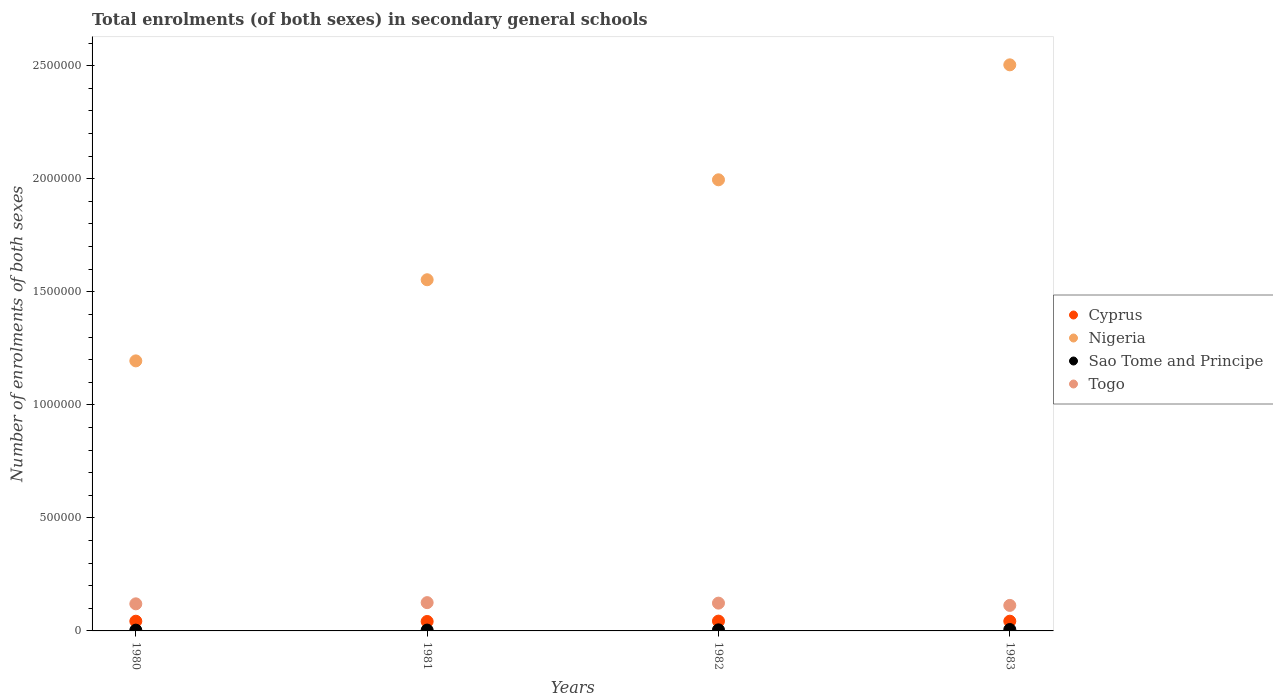How many different coloured dotlines are there?
Your answer should be very brief. 4. Is the number of dotlines equal to the number of legend labels?
Provide a short and direct response. Yes. What is the number of enrolments in secondary schools in Nigeria in 1980?
Keep it short and to the point. 1.19e+06. Across all years, what is the maximum number of enrolments in secondary schools in Nigeria?
Keep it short and to the point. 2.50e+06. Across all years, what is the minimum number of enrolments in secondary schools in Nigeria?
Your answer should be compact. 1.19e+06. In which year was the number of enrolments in secondary schools in Cyprus maximum?
Keep it short and to the point. 1982. In which year was the number of enrolments in secondary schools in Sao Tome and Principe minimum?
Give a very brief answer. 1980. What is the total number of enrolments in secondary schools in Sao Tome and Principe in the graph?
Ensure brevity in your answer.  1.80e+04. What is the difference between the number of enrolments in secondary schools in Sao Tome and Principe in 1981 and that in 1983?
Your response must be concise. -2475. What is the difference between the number of enrolments in secondary schools in Nigeria in 1983 and the number of enrolments in secondary schools in Cyprus in 1980?
Give a very brief answer. 2.46e+06. What is the average number of enrolments in secondary schools in Togo per year?
Make the answer very short. 1.20e+05. In the year 1983, what is the difference between the number of enrolments in secondary schools in Togo and number of enrolments in secondary schools in Nigeria?
Your answer should be very brief. -2.39e+06. What is the ratio of the number of enrolments in secondary schools in Cyprus in 1981 to that in 1983?
Provide a short and direct response. 0.97. Is the difference between the number of enrolments in secondary schools in Togo in 1980 and 1982 greater than the difference between the number of enrolments in secondary schools in Nigeria in 1980 and 1982?
Your response must be concise. Yes. What is the difference between the highest and the second highest number of enrolments in secondary schools in Sao Tome and Principe?
Ensure brevity in your answer.  1462. What is the difference between the highest and the lowest number of enrolments in secondary schools in Cyprus?
Your answer should be compact. 1544. Is the sum of the number of enrolments in secondary schools in Togo in 1982 and 1983 greater than the maximum number of enrolments in secondary schools in Cyprus across all years?
Give a very brief answer. Yes. Is it the case that in every year, the sum of the number of enrolments in secondary schools in Nigeria and number of enrolments in secondary schools in Togo  is greater than the number of enrolments in secondary schools in Cyprus?
Offer a terse response. Yes. Does the number of enrolments in secondary schools in Cyprus monotonically increase over the years?
Offer a very short reply. No. Is the number of enrolments in secondary schools in Cyprus strictly greater than the number of enrolments in secondary schools in Nigeria over the years?
Your answer should be very brief. No. How many dotlines are there?
Give a very brief answer. 4. How many years are there in the graph?
Provide a short and direct response. 4. Are the values on the major ticks of Y-axis written in scientific E-notation?
Offer a very short reply. No. Does the graph contain any zero values?
Your response must be concise. No. Where does the legend appear in the graph?
Make the answer very short. Center right. How many legend labels are there?
Make the answer very short. 4. What is the title of the graph?
Your answer should be very brief. Total enrolments (of both sexes) in secondary general schools. What is the label or title of the Y-axis?
Keep it short and to the point. Number of enrolments of both sexes. What is the Number of enrolments of both sexes of Cyprus in 1980?
Provide a short and direct response. 4.30e+04. What is the Number of enrolments of both sexes of Nigeria in 1980?
Make the answer very short. 1.19e+06. What is the Number of enrolments of both sexes in Sao Tome and Principe in 1980?
Offer a terse response. 3415. What is the Number of enrolments of both sexes of Togo in 1980?
Your response must be concise. 1.20e+05. What is the Number of enrolments of both sexes of Cyprus in 1981?
Your answer should be very brief. 4.18e+04. What is the Number of enrolments of both sexes in Nigeria in 1981?
Your answer should be very brief. 1.55e+06. What is the Number of enrolments of both sexes of Sao Tome and Principe in 1981?
Keep it short and to the point. 3685. What is the Number of enrolments of both sexes in Togo in 1981?
Offer a terse response. 1.25e+05. What is the Number of enrolments of both sexes of Cyprus in 1982?
Provide a succinct answer. 4.33e+04. What is the Number of enrolments of both sexes of Nigeria in 1982?
Ensure brevity in your answer.  2.00e+06. What is the Number of enrolments of both sexes of Sao Tome and Principe in 1982?
Your answer should be compact. 4698. What is the Number of enrolments of both sexes of Togo in 1982?
Your response must be concise. 1.23e+05. What is the Number of enrolments of both sexes of Cyprus in 1983?
Keep it short and to the point. 4.30e+04. What is the Number of enrolments of both sexes in Nigeria in 1983?
Your answer should be very brief. 2.50e+06. What is the Number of enrolments of both sexes of Sao Tome and Principe in 1983?
Offer a terse response. 6160. What is the Number of enrolments of both sexes in Togo in 1983?
Give a very brief answer. 1.13e+05. Across all years, what is the maximum Number of enrolments of both sexes of Cyprus?
Offer a terse response. 4.33e+04. Across all years, what is the maximum Number of enrolments of both sexes of Nigeria?
Provide a succinct answer. 2.50e+06. Across all years, what is the maximum Number of enrolments of both sexes of Sao Tome and Principe?
Offer a terse response. 6160. Across all years, what is the maximum Number of enrolments of both sexes in Togo?
Your response must be concise. 1.25e+05. Across all years, what is the minimum Number of enrolments of both sexes in Cyprus?
Your answer should be compact. 4.18e+04. Across all years, what is the minimum Number of enrolments of both sexes of Nigeria?
Your answer should be compact. 1.19e+06. Across all years, what is the minimum Number of enrolments of both sexes in Sao Tome and Principe?
Your answer should be very brief. 3415. Across all years, what is the minimum Number of enrolments of both sexes in Togo?
Your answer should be compact. 1.13e+05. What is the total Number of enrolments of both sexes of Cyprus in the graph?
Provide a short and direct response. 1.71e+05. What is the total Number of enrolments of both sexes of Nigeria in the graph?
Your answer should be very brief. 7.25e+06. What is the total Number of enrolments of both sexes of Sao Tome and Principe in the graph?
Your answer should be compact. 1.80e+04. What is the total Number of enrolments of both sexes of Togo in the graph?
Keep it short and to the point. 4.81e+05. What is the difference between the Number of enrolments of both sexes of Cyprus in 1980 and that in 1981?
Your answer should be very brief. 1163. What is the difference between the Number of enrolments of both sexes in Nigeria in 1980 and that in 1981?
Your answer should be compact. -3.59e+05. What is the difference between the Number of enrolments of both sexes in Sao Tome and Principe in 1980 and that in 1981?
Your answer should be very brief. -270. What is the difference between the Number of enrolments of both sexes of Togo in 1980 and that in 1981?
Your answer should be very brief. -5321. What is the difference between the Number of enrolments of both sexes in Cyprus in 1980 and that in 1982?
Your response must be concise. -381. What is the difference between the Number of enrolments of both sexes of Nigeria in 1980 and that in 1982?
Keep it short and to the point. -8.01e+05. What is the difference between the Number of enrolments of both sexes of Sao Tome and Principe in 1980 and that in 1982?
Provide a short and direct response. -1283. What is the difference between the Number of enrolments of both sexes of Togo in 1980 and that in 1982?
Provide a succinct answer. -3124. What is the difference between the Number of enrolments of both sexes in Cyprus in 1980 and that in 1983?
Ensure brevity in your answer.  -43. What is the difference between the Number of enrolments of both sexes of Nigeria in 1980 and that in 1983?
Provide a succinct answer. -1.31e+06. What is the difference between the Number of enrolments of both sexes in Sao Tome and Principe in 1980 and that in 1983?
Offer a terse response. -2745. What is the difference between the Number of enrolments of both sexes in Togo in 1980 and that in 1983?
Offer a very short reply. 6940. What is the difference between the Number of enrolments of both sexes in Cyprus in 1981 and that in 1982?
Your answer should be very brief. -1544. What is the difference between the Number of enrolments of both sexes in Nigeria in 1981 and that in 1982?
Keep it short and to the point. -4.42e+05. What is the difference between the Number of enrolments of both sexes of Sao Tome and Principe in 1981 and that in 1982?
Your response must be concise. -1013. What is the difference between the Number of enrolments of both sexes of Togo in 1981 and that in 1982?
Ensure brevity in your answer.  2197. What is the difference between the Number of enrolments of both sexes of Cyprus in 1981 and that in 1983?
Keep it short and to the point. -1206. What is the difference between the Number of enrolments of both sexes of Nigeria in 1981 and that in 1983?
Keep it short and to the point. -9.51e+05. What is the difference between the Number of enrolments of both sexes in Sao Tome and Principe in 1981 and that in 1983?
Your answer should be compact. -2475. What is the difference between the Number of enrolments of both sexes of Togo in 1981 and that in 1983?
Your response must be concise. 1.23e+04. What is the difference between the Number of enrolments of both sexes in Cyprus in 1982 and that in 1983?
Make the answer very short. 338. What is the difference between the Number of enrolments of both sexes of Nigeria in 1982 and that in 1983?
Ensure brevity in your answer.  -5.09e+05. What is the difference between the Number of enrolments of both sexes of Sao Tome and Principe in 1982 and that in 1983?
Keep it short and to the point. -1462. What is the difference between the Number of enrolments of both sexes of Togo in 1982 and that in 1983?
Give a very brief answer. 1.01e+04. What is the difference between the Number of enrolments of both sexes in Cyprus in 1980 and the Number of enrolments of both sexes in Nigeria in 1981?
Your response must be concise. -1.51e+06. What is the difference between the Number of enrolments of both sexes in Cyprus in 1980 and the Number of enrolments of both sexes in Sao Tome and Principe in 1981?
Your answer should be compact. 3.93e+04. What is the difference between the Number of enrolments of both sexes of Cyprus in 1980 and the Number of enrolments of both sexes of Togo in 1981?
Ensure brevity in your answer.  -8.22e+04. What is the difference between the Number of enrolments of both sexes in Nigeria in 1980 and the Number of enrolments of both sexes in Sao Tome and Principe in 1981?
Ensure brevity in your answer.  1.19e+06. What is the difference between the Number of enrolments of both sexes in Nigeria in 1980 and the Number of enrolments of both sexes in Togo in 1981?
Give a very brief answer. 1.07e+06. What is the difference between the Number of enrolments of both sexes in Sao Tome and Principe in 1980 and the Number of enrolments of both sexes in Togo in 1981?
Ensure brevity in your answer.  -1.22e+05. What is the difference between the Number of enrolments of both sexes in Cyprus in 1980 and the Number of enrolments of both sexes in Nigeria in 1982?
Offer a terse response. -1.95e+06. What is the difference between the Number of enrolments of both sexes in Cyprus in 1980 and the Number of enrolments of both sexes in Sao Tome and Principe in 1982?
Provide a short and direct response. 3.83e+04. What is the difference between the Number of enrolments of both sexes of Cyprus in 1980 and the Number of enrolments of both sexes of Togo in 1982?
Your answer should be very brief. -8.00e+04. What is the difference between the Number of enrolments of both sexes in Nigeria in 1980 and the Number of enrolments of both sexes in Sao Tome and Principe in 1982?
Give a very brief answer. 1.19e+06. What is the difference between the Number of enrolments of both sexes in Nigeria in 1980 and the Number of enrolments of both sexes in Togo in 1982?
Give a very brief answer. 1.07e+06. What is the difference between the Number of enrolments of both sexes in Sao Tome and Principe in 1980 and the Number of enrolments of both sexes in Togo in 1982?
Provide a succinct answer. -1.20e+05. What is the difference between the Number of enrolments of both sexes in Cyprus in 1980 and the Number of enrolments of both sexes in Nigeria in 1983?
Offer a very short reply. -2.46e+06. What is the difference between the Number of enrolments of both sexes in Cyprus in 1980 and the Number of enrolments of both sexes in Sao Tome and Principe in 1983?
Offer a very short reply. 3.68e+04. What is the difference between the Number of enrolments of both sexes of Cyprus in 1980 and the Number of enrolments of both sexes of Togo in 1983?
Offer a terse response. -6.99e+04. What is the difference between the Number of enrolments of both sexes in Nigeria in 1980 and the Number of enrolments of both sexes in Sao Tome and Principe in 1983?
Ensure brevity in your answer.  1.19e+06. What is the difference between the Number of enrolments of both sexes in Nigeria in 1980 and the Number of enrolments of both sexes in Togo in 1983?
Provide a succinct answer. 1.08e+06. What is the difference between the Number of enrolments of both sexes of Sao Tome and Principe in 1980 and the Number of enrolments of both sexes of Togo in 1983?
Provide a succinct answer. -1.09e+05. What is the difference between the Number of enrolments of both sexes of Cyprus in 1981 and the Number of enrolments of both sexes of Nigeria in 1982?
Your response must be concise. -1.95e+06. What is the difference between the Number of enrolments of both sexes in Cyprus in 1981 and the Number of enrolments of both sexes in Sao Tome and Principe in 1982?
Keep it short and to the point. 3.71e+04. What is the difference between the Number of enrolments of both sexes of Cyprus in 1981 and the Number of enrolments of both sexes of Togo in 1982?
Provide a succinct answer. -8.11e+04. What is the difference between the Number of enrolments of both sexes of Nigeria in 1981 and the Number of enrolments of both sexes of Sao Tome and Principe in 1982?
Your answer should be compact. 1.55e+06. What is the difference between the Number of enrolments of both sexes in Nigeria in 1981 and the Number of enrolments of both sexes in Togo in 1982?
Your answer should be very brief. 1.43e+06. What is the difference between the Number of enrolments of both sexes of Sao Tome and Principe in 1981 and the Number of enrolments of both sexes of Togo in 1982?
Give a very brief answer. -1.19e+05. What is the difference between the Number of enrolments of both sexes of Cyprus in 1981 and the Number of enrolments of both sexes of Nigeria in 1983?
Your response must be concise. -2.46e+06. What is the difference between the Number of enrolments of both sexes in Cyprus in 1981 and the Number of enrolments of both sexes in Sao Tome and Principe in 1983?
Your answer should be compact. 3.56e+04. What is the difference between the Number of enrolments of both sexes in Cyprus in 1981 and the Number of enrolments of both sexes in Togo in 1983?
Offer a very short reply. -7.11e+04. What is the difference between the Number of enrolments of both sexes of Nigeria in 1981 and the Number of enrolments of both sexes of Sao Tome and Principe in 1983?
Make the answer very short. 1.55e+06. What is the difference between the Number of enrolments of both sexes of Nigeria in 1981 and the Number of enrolments of both sexes of Togo in 1983?
Offer a very short reply. 1.44e+06. What is the difference between the Number of enrolments of both sexes in Sao Tome and Principe in 1981 and the Number of enrolments of both sexes in Togo in 1983?
Make the answer very short. -1.09e+05. What is the difference between the Number of enrolments of both sexes in Cyprus in 1982 and the Number of enrolments of both sexes in Nigeria in 1983?
Provide a succinct answer. -2.46e+06. What is the difference between the Number of enrolments of both sexes in Cyprus in 1982 and the Number of enrolments of both sexes in Sao Tome and Principe in 1983?
Offer a very short reply. 3.72e+04. What is the difference between the Number of enrolments of both sexes in Cyprus in 1982 and the Number of enrolments of both sexes in Togo in 1983?
Your response must be concise. -6.95e+04. What is the difference between the Number of enrolments of both sexes in Nigeria in 1982 and the Number of enrolments of both sexes in Sao Tome and Principe in 1983?
Give a very brief answer. 1.99e+06. What is the difference between the Number of enrolments of both sexes of Nigeria in 1982 and the Number of enrolments of both sexes of Togo in 1983?
Your answer should be compact. 1.88e+06. What is the difference between the Number of enrolments of both sexes of Sao Tome and Principe in 1982 and the Number of enrolments of both sexes of Togo in 1983?
Offer a terse response. -1.08e+05. What is the average Number of enrolments of both sexes in Cyprus per year?
Your response must be concise. 4.28e+04. What is the average Number of enrolments of both sexes of Nigeria per year?
Your answer should be compact. 1.81e+06. What is the average Number of enrolments of both sexes of Sao Tome and Principe per year?
Ensure brevity in your answer.  4489.5. What is the average Number of enrolments of both sexes in Togo per year?
Provide a short and direct response. 1.20e+05. In the year 1980, what is the difference between the Number of enrolments of both sexes of Cyprus and Number of enrolments of both sexes of Nigeria?
Provide a short and direct response. -1.15e+06. In the year 1980, what is the difference between the Number of enrolments of both sexes of Cyprus and Number of enrolments of both sexes of Sao Tome and Principe?
Give a very brief answer. 3.95e+04. In the year 1980, what is the difference between the Number of enrolments of both sexes in Cyprus and Number of enrolments of both sexes in Togo?
Provide a short and direct response. -7.68e+04. In the year 1980, what is the difference between the Number of enrolments of both sexes in Nigeria and Number of enrolments of both sexes in Sao Tome and Principe?
Give a very brief answer. 1.19e+06. In the year 1980, what is the difference between the Number of enrolments of both sexes of Nigeria and Number of enrolments of both sexes of Togo?
Ensure brevity in your answer.  1.07e+06. In the year 1980, what is the difference between the Number of enrolments of both sexes in Sao Tome and Principe and Number of enrolments of both sexes in Togo?
Make the answer very short. -1.16e+05. In the year 1981, what is the difference between the Number of enrolments of both sexes of Cyprus and Number of enrolments of both sexes of Nigeria?
Your answer should be compact. -1.51e+06. In the year 1981, what is the difference between the Number of enrolments of both sexes of Cyprus and Number of enrolments of both sexes of Sao Tome and Principe?
Give a very brief answer. 3.81e+04. In the year 1981, what is the difference between the Number of enrolments of both sexes of Cyprus and Number of enrolments of both sexes of Togo?
Ensure brevity in your answer.  -8.33e+04. In the year 1981, what is the difference between the Number of enrolments of both sexes of Nigeria and Number of enrolments of both sexes of Sao Tome and Principe?
Offer a terse response. 1.55e+06. In the year 1981, what is the difference between the Number of enrolments of both sexes in Nigeria and Number of enrolments of both sexes in Togo?
Your answer should be compact. 1.43e+06. In the year 1981, what is the difference between the Number of enrolments of both sexes of Sao Tome and Principe and Number of enrolments of both sexes of Togo?
Provide a short and direct response. -1.21e+05. In the year 1982, what is the difference between the Number of enrolments of both sexes of Cyprus and Number of enrolments of both sexes of Nigeria?
Your answer should be compact. -1.95e+06. In the year 1982, what is the difference between the Number of enrolments of both sexes in Cyprus and Number of enrolments of both sexes in Sao Tome and Principe?
Give a very brief answer. 3.86e+04. In the year 1982, what is the difference between the Number of enrolments of both sexes of Cyprus and Number of enrolments of both sexes of Togo?
Your answer should be very brief. -7.96e+04. In the year 1982, what is the difference between the Number of enrolments of both sexes in Nigeria and Number of enrolments of both sexes in Sao Tome and Principe?
Your answer should be compact. 1.99e+06. In the year 1982, what is the difference between the Number of enrolments of both sexes in Nigeria and Number of enrolments of both sexes in Togo?
Ensure brevity in your answer.  1.87e+06. In the year 1982, what is the difference between the Number of enrolments of both sexes of Sao Tome and Principe and Number of enrolments of both sexes of Togo?
Provide a succinct answer. -1.18e+05. In the year 1983, what is the difference between the Number of enrolments of both sexes of Cyprus and Number of enrolments of both sexes of Nigeria?
Give a very brief answer. -2.46e+06. In the year 1983, what is the difference between the Number of enrolments of both sexes in Cyprus and Number of enrolments of both sexes in Sao Tome and Principe?
Offer a very short reply. 3.68e+04. In the year 1983, what is the difference between the Number of enrolments of both sexes in Cyprus and Number of enrolments of both sexes in Togo?
Give a very brief answer. -6.99e+04. In the year 1983, what is the difference between the Number of enrolments of both sexes of Nigeria and Number of enrolments of both sexes of Sao Tome and Principe?
Your answer should be compact. 2.50e+06. In the year 1983, what is the difference between the Number of enrolments of both sexes of Nigeria and Number of enrolments of both sexes of Togo?
Ensure brevity in your answer.  2.39e+06. In the year 1983, what is the difference between the Number of enrolments of both sexes of Sao Tome and Principe and Number of enrolments of both sexes of Togo?
Offer a terse response. -1.07e+05. What is the ratio of the Number of enrolments of both sexes of Cyprus in 1980 to that in 1981?
Your answer should be compact. 1.03. What is the ratio of the Number of enrolments of both sexes of Nigeria in 1980 to that in 1981?
Your answer should be very brief. 0.77. What is the ratio of the Number of enrolments of both sexes of Sao Tome and Principe in 1980 to that in 1981?
Your response must be concise. 0.93. What is the ratio of the Number of enrolments of both sexes of Togo in 1980 to that in 1981?
Offer a very short reply. 0.96. What is the ratio of the Number of enrolments of both sexes of Nigeria in 1980 to that in 1982?
Offer a very short reply. 0.6. What is the ratio of the Number of enrolments of both sexes of Sao Tome and Principe in 1980 to that in 1982?
Keep it short and to the point. 0.73. What is the ratio of the Number of enrolments of both sexes in Togo in 1980 to that in 1982?
Ensure brevity in your answer.  0.97. What is the ratio of the Number of enrolments of both sexes of Cyprus in 1980 to that in 1983?
Ensure brevity in your answer.  1. What is the ratio of the Number of enrolments of both sexes in Nigeria in 1980 to that in 1983?
Offer a very short reply. 0.48. What is the ratio of the Number of enrolments of both sexes of Sao Tome and Principe in 1980 to that in 1983?
Keep it short and to the point. 0.55. What is the ratio of the Number of enrolments of both sexes of Togo in 1980 to that in 1983?
Provide a succinct answer. 1.06. What is the ratio of the Number of enrolments of both sexes of Cyprus in 1981 to that in 1982?
Provide a short and direct response. 0.96. What is the ratio of the Number of enrolments of both sexes in Nigeria in 1981 to that in 1982?
Keep it short and to the point. 0.78. What is the ratio of the Number of enrolments of both sexes in Sao Tome and Principe in 1981 to that in 1982?
Keep it short and to the point. 0.78. What is the ratio of the Number of enrolments of both sexes in Togo in 1981 to that in 1982?
Your answer should be very brief. 1.02. What is the ratio of the Number of enrolments of both sexes of Nigeria in 1981 to that in 1983?
Provide a short and direct response. 0.62. What is the ratio of the Number of enrolments of both sexes in Sao Tome and Principe in 1981 to that in 1983?
Provide a succinct answer. 0.6. What is the ratio of the Number of enrolments of both sexes of Togo in 1981 to that in 1983?
Provide a short and direct response. 1.11. What is the ratio of the Number of enrolments of both sexes of Cyprus in 1982 to that in 1983?
Offer a very short reply. 1.01. What is the ratio of the Number of enrolments of both sexes in Nigeria in 1982 to that in 1983?
Your response must be concise. 0.8. What is the ratio of the Number of enrolments of both sexes in Sao Tome and Principe in 1982 to that in 1983?
Provide a short and direct response. 0.76. What is the ratio of the Number of enrolments of both sexes in Togo in 1982 to that in 1983?
Keep it short and to the point. 1.09. What is the difference between the highest and the second highest Number of enrolments of both sexes in Cyprus?
Provide a short and direct response. 338. What is the difference between the highest and the second highest Number of enrolments of both sexes of Nigeria?
Keep it short and to the point. 5.09e+05. What is the difference between the highest and the second highest Number of enrolments of both sexes in Sao Tome and Principe?
Give a very brief answer. 1462. What is the difference between the highest and the second highest Number of enrolments of both sexes of Togo?
Ensure brevity in your answer.  2197. What is the difference between the highest and the lowest Number of enrolments of both sexes of Cyprus?
Provide a succinct answer. 1544. What is the difference between the highest and the lowest Number of enrolments of both sexes in Nigeria?
Provide a succinct answer. 1.31e+06. What is the difference between the highest and the lowest Number of enrolments of both sexes in Sao Tome and Principe?
Keep it short and to the point. 2745. What is the difference between the highest and the lowest Number of enrolments of both sexes of Togo?
Keep it short and to the point. 1.23e+04. 